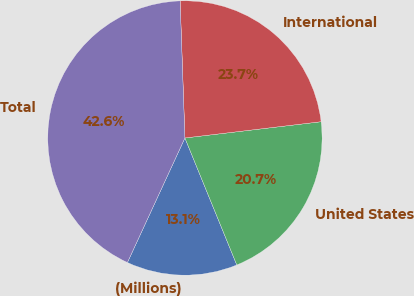Convert chart. <chart><loc_0><loc_0><loc_500><loc_500><pie_chart><fcel>(Millions)<fcel>United States<fcel>International<fcel>Total<nl><fcel>13.06%<fcel>20.72%<fcel>23.67%<fcel>42.56%<nl></chart> 